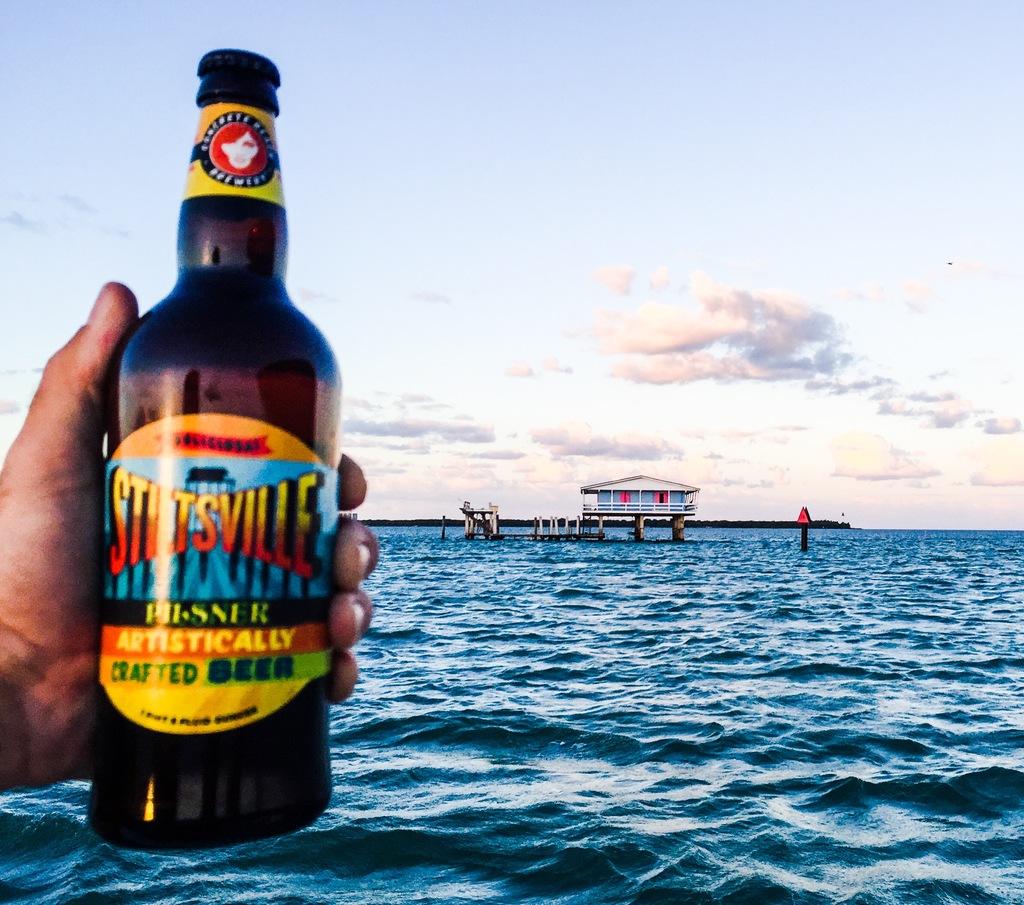What type of beverage is in the bottle?
Your answer should be compact. Beer. What kind of crafted beer is this?
Provide a short and direct response. Artistically. 